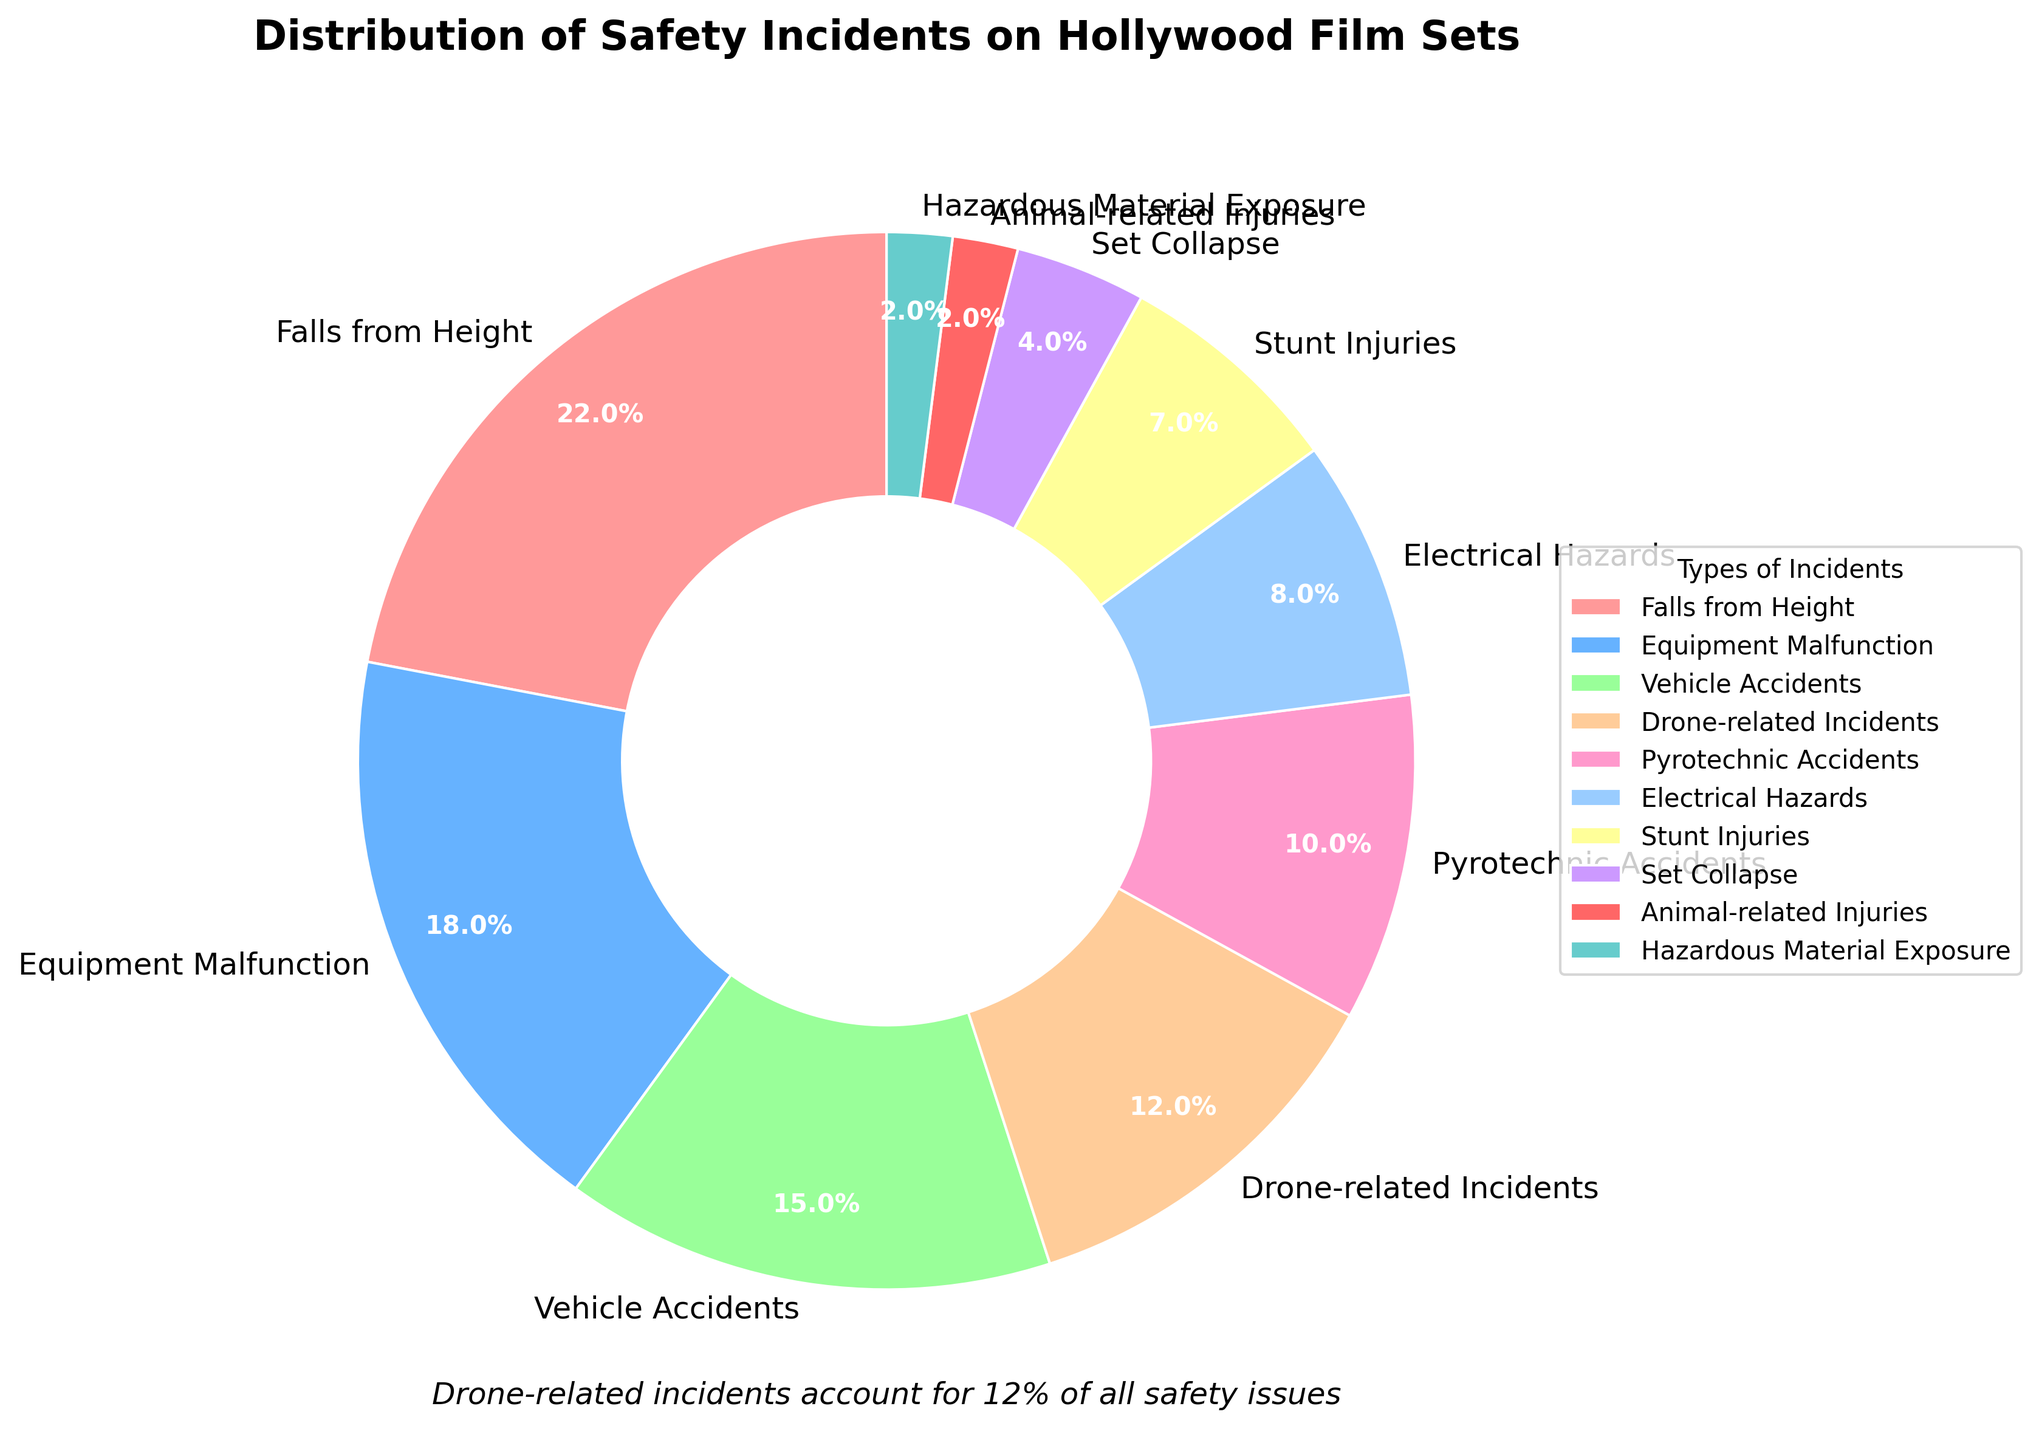What percentage of safety incidents are accounted for by falls from height and equipment malfunction combined? To find the combined percentage of falls from height and equipment malfunction, add their respective percentages from the chart: 22% (falls from height) + 18% (equipment malfunction) = 40%.
Answer: 40% Which type of safety incident has a higher percentage: vehicle accidents or drone-related incidents? Compare the percentages of vehicle accidents and drone-related incidents from the chart. Vehicle accidents account for 15%, while drone-related incidents account for 12%. Therefore, vehicle accidents have a higher percentage.
Answer: Vehicle accidents What is the difference in percentage between the highest and lowest categories of safety incidents? Identify the highest and lowest percentages from the chart. Falls from height is the highest at 22%, and both animal-related injuries and hazardous material exposure are the lowest at 2%. The difference is 22% - 2% = 20%.
Answer: 20% How many incident types individually account for less than 10% of all safety incidents? Count the number of incident types that have percentages less than 10% from the chart: Electrical Hazards (8%), Stunt Injuries (7%), Set Collapse (4%), Animal-related Injuries (2%), and Hazardous Material Exposure (2%). There are 5 such categories.
Answer: 5 What percentage of safety incidents do stunt injuries and set collapse account for in total? Sum the percentages for stunt injuries and set collapse from the chart: 7% (stunt injuries) + 4% (set collapse) = 11%.
Answer: 11% Which type of safety incident is closest in percentage to electrical hazards? Look for a safety incident with a percentage close to electrical hazards (which is 8%). Stunt injuries, at 7%, is the closest.
Answer: Stunt injuries How much greater is the sum of vehicle accidents, falls from height, and equipment malfunction percentages compared to the sum of drone-related incidents, pyrotechnic accidents, and electrical hazards? First, calculate the sum for vehicle accidents, falls from height, and equipment malfunction: 15% + 22% + 18% = 55%. Next, calculate the sum for drone-related incidents, pyrotechnic accidents, and electrical hazards: 12% + 10% + 8% = 30%. The difference is 55% - 30% = 25%.
Answer: 25% What two types of incidents combined make up 30% of the safety incidents? Review the chart for incident types whose combined percentages equal 30%. Equipment malfunction (18%) and electrical hazards (8%) combined with any 4% category (set collapse) make up 30%, but reviewing options properly would be Equipment Malfunction and Vehicle Accidents 18%+12%=30%.
Answer: Equipment Malfunction and Vehicle Accidents What types of incidents have percentages displayed in bold on the chart? Since all percentages are shown in bold as per the customization in the chart, all the incident types have their percentages displayed in bold.
Answer: All types What is the most frequently occurring color among the wedges in the pie chart, based on the described custom colors? The colors described (pink, blue, green, orange, etc.) occur once each, meaning there isn't one color that occurs more frequently than others. All colors occur equally often.
Answer: All colorsoccur equally 